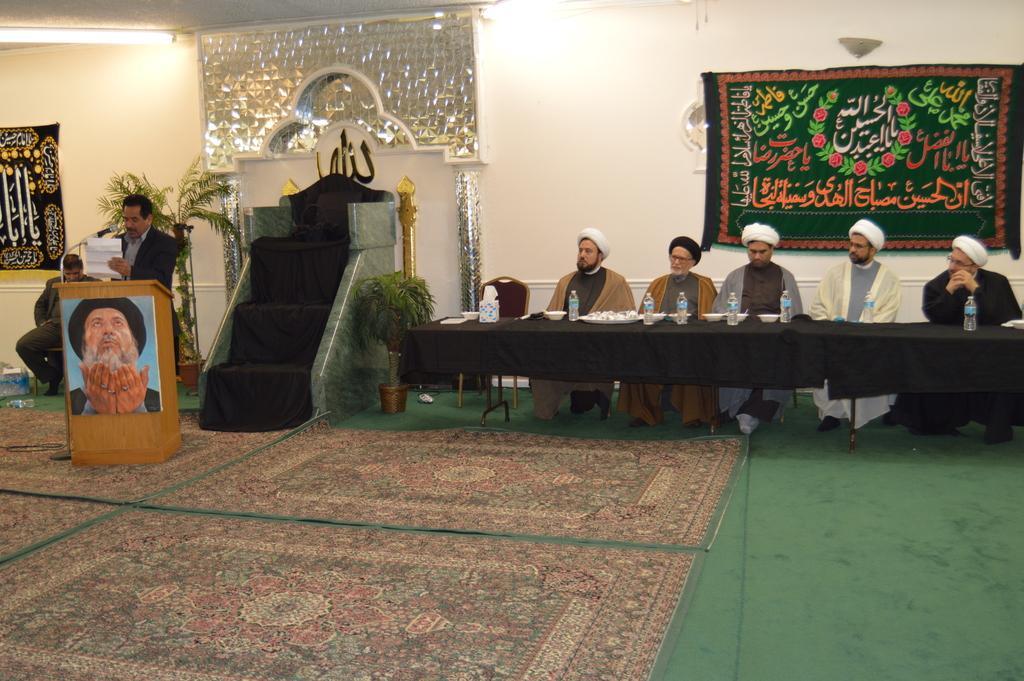Can you describe this image briefly? In this image I can see a conference table with chairs and some people sitting in chairs I can see a carpet hanging on the wall behind them. I can see carpets on the floor at the bottom of the image. I can see a person standing and talking in a mike holding a paper. I can see a photograph sticked to the wooden desk. I can see another person on the left hand side and a carpet hanging behind him. I can see some potted plants and steps with a carved background wall. 